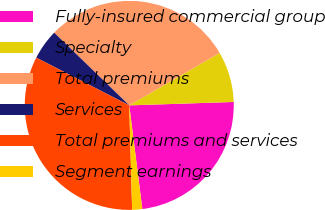Convert chart to OTSL. <chart><loc_0><loc_0><loc_500><loc_500><pie_chart><fcel>Fully-insured commercial group<fcel>Specialty<fcel>Total premiums<fcel>Services<fcel>Total premiums and services<fcel>Segment earnings<nl><fcel>23.52%<fcel>7.85%<fcel>29.39%<fcel>4.7%<fcel>32.99%<fcel>1.56%<nl></chart> 